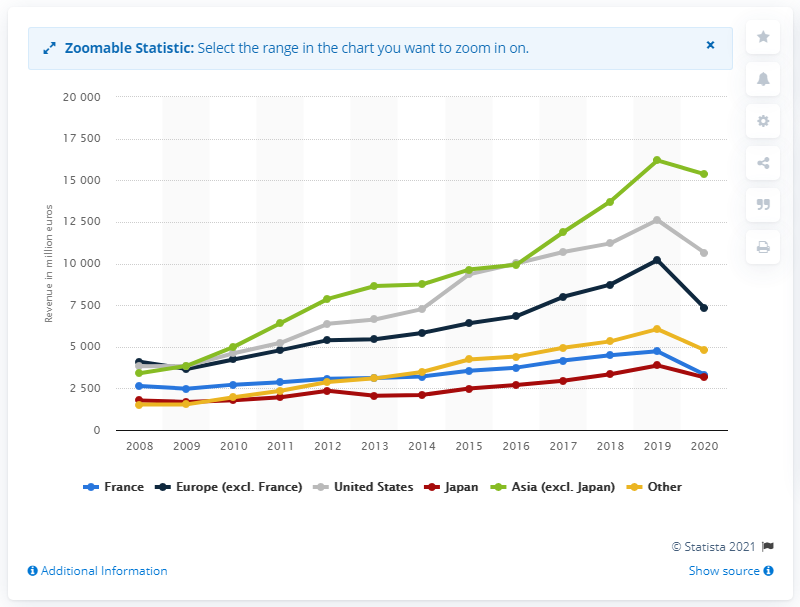Indicate a few pertinent items in this graphic. In 2020, the LVMH Group generated approximately $106,470 in revenue in the United States. 